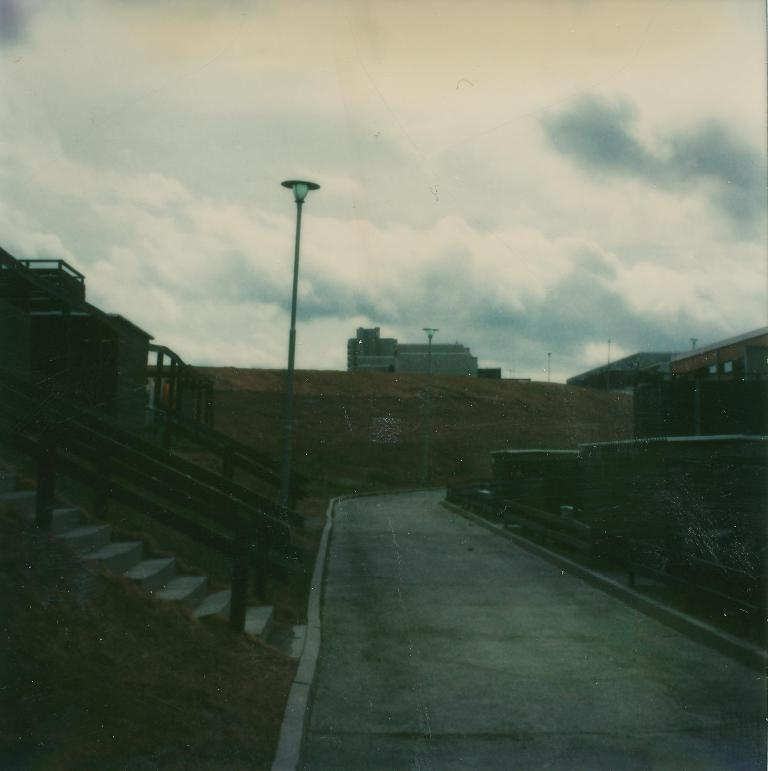What can be seen in the sky in the image? The sky with clouds is visible in the image. What type of structures are present in the image? There are buildings in the image. What are the vertical structures on the sides of the road? Street poles are present in the image. What are the light sources on the street poles? Street lights are visible in the image. What is the surface on which people and vehicles move? The ground is visible in the image. What is a feature that allows people to move between different levels? There is a staircase in the image. What are the long, thin bars used for in the image? Railings are present in the image. What is the path for vehicles and pedestrians in the image? A road is visible in the image. What type of skirt is being worn by the cloud in the image? There are no clouds or skirts present in the image; it only shows a sky with clouds. How many legs can be seen supporting the buildings in the image? There are no legs visible in the image; it only shows buildings, street poles, and other structures. 